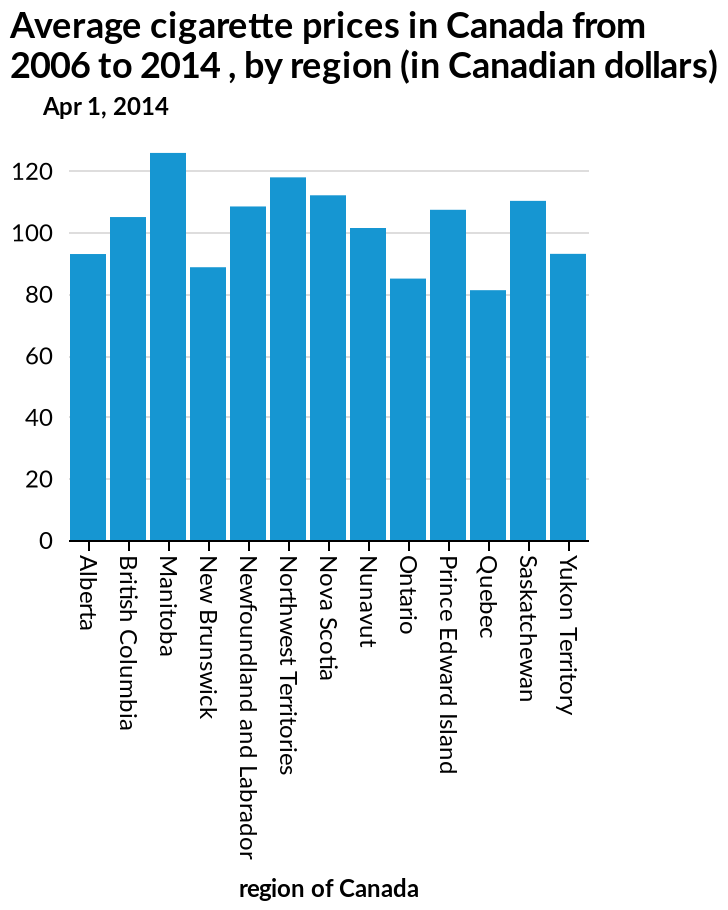<image>
Offer a thorough analysis of the image. Cigarettes cost more than 80 Canadian dollars across all locations. Manitoba has the highest cost of cigarettes. Quebec has the lowest cost of cigarettes. Which province has the third highest average cigarette prices? Saskatchewan has the third highest average cigarette prices with 110 dollars. please summary the statistics and relations of the chart Manitoba has the highest average cigarette prices, with just over 120 dollars. Quebec has the lowest average cigarette prices with 80 dollars. Northwest Territories has the second highest average cigarette prices with just under 120 dollars. Saskatchewan has the third highest average cigarette prices with 110 dollars. 